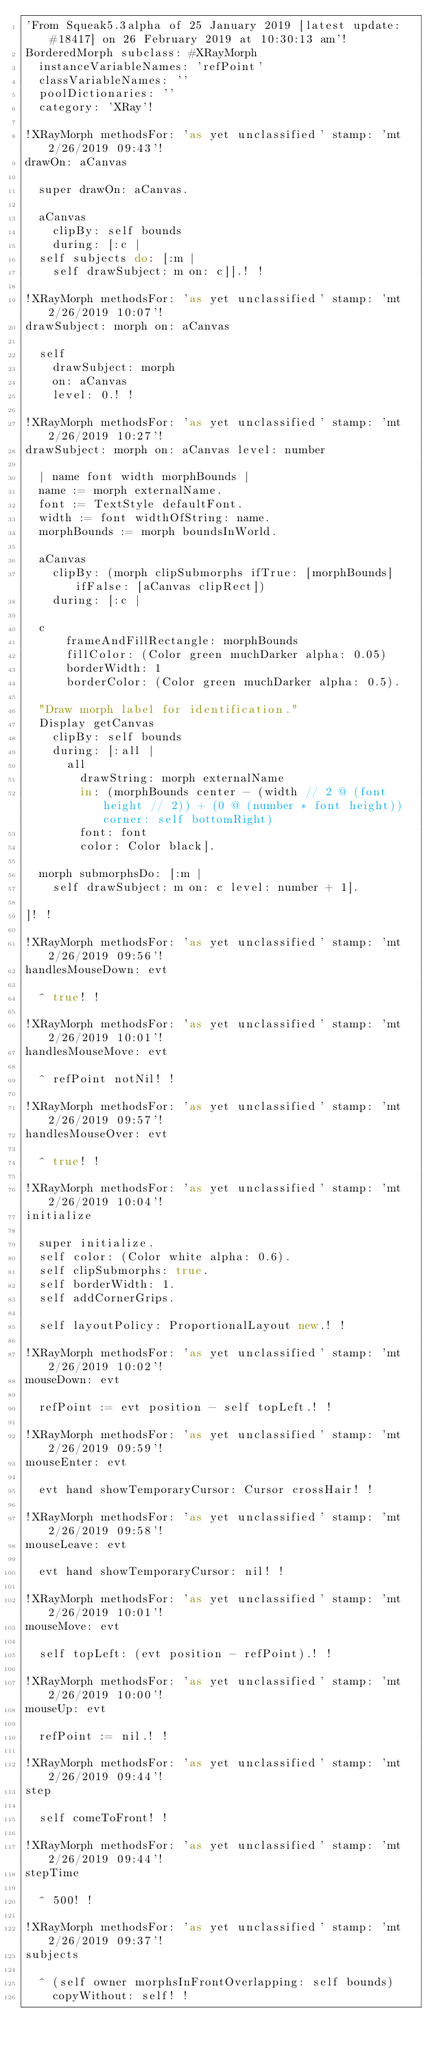<code> <loc_0><loc_0><loc_500><loc_500><_C#_>'From Squeak5.3alpha of 25 January 2019 [latest update: #18417] on 26 February 2019 at 10:30:13 am'!BorderedMorph subclass: #XRayMorph	instanceVariableNames: 'refPoint'	classVariableNames: ''	poolDictionaries: ''	category: 'XRay'!!XRayMorph methodsFor: 'as yet unclassified' stamp: 'mt 2/26/2019 09:43'!drawOn: aCanvas	super drawOn: aCanvas.	aCanvas		clipBy: self bounds		during: [:c |	self subjects do: [:m |		self drawSubject: m on: c]].! !!XRayMorph methodsFor: 'as yet unclassified' stamp: 'mt 2/26/2019 10:07'!drawSubject: morph on: aCanvas	self		drawSubject: morph		on: aCanvas		level: 0.! !!XRayMorph methodsFor: 'as yet unclassified' stamp: 'mt 2/26/2019 10:27'!drawSubject: morph on: aCanvas level: number	| name font width morphBounds |	name := morph externalName.	font := TextStyle defaultFont.	width := font widthOfString: name.	morphBounds := morph boundsInWorld. 	aCanvas		clipBy: (morph clipSubmorphs ifTrue: [morphBounds] ifFalse: [aCanvas clipRect])		during: [:c |	c			frameAndFillRectangle: morphBounds			fillColor: (Color green muchDarker alpha: 0.05)			borderWidth: 1			borderColor: (Color green muchDarker alpha: 0.5).	"Draw morph label for identification."	Display getCanvas		clipBy: self bounds		during: [:all |			all				drawString: morph externalName				in: (morphBounds center - (width // 2 @ (font height // 2)) + (0 @ (number * font height)) corner: self bottomRight)				font: font				color: Color black].	morph submorphsDo: [:m |		self drawSubject: m on: c level: number + 1].	]! !!XRayMorph methodsFor: 'as yet unclassified' stamp: 'mt 2/26/2019 09:56'!handlesMouseDown: evt	^ true! !!XRayMorph methodsFor: 'as yet unclassified' stamp: 'mt 2/26/2019 10:01'!handlesMouseMove: evt	^ refPoint notNil! !!XRayMorph methodsFor: 'as yet unclassified' stamp: 'mt 2/26/2019 09:57'!handlesMouseOver: evt	^ true! !!XRayMorph methodsFor: 'as yet unclassified' stamp: 'mt 2/26/2019 10:04'!initialize	super initialize.	self color: (Color white alpha: 0.6).	self clipSubmorphs: true.	self borderWidth: 1.	self addCornerGrips.		self layoutPolicy: ProportionalLayout new.! !!XRayMorph methodsFor: 'as yet unclassified' stamp: 'mt 2/26/2019 10:02'!mouseDown: evt	refPoint := evt position - self topLeft.! !!XRayMorph methodsFor: 'as yet unclassified' stamp: 'mt 2/26/2019 09:59'!mouseEnter: evt	evt hand showTemporaryCursor: Cursor crossHair! !!XRayMorph methodsFor: 'as yet unclassified' stamp: 'mt 2/26/2019 09:58'!mouseLeave: evt	evt hand showTemporaryCursor: nil! !!XRayMorph methodsFor: 'as yet unclassified' stamp: 'mt 2/26/2019 10:01'!mouseMove: evt	self topLeft: (evt position - refPoint).! !!XRayMorph methodsFor: 'as yet unclassified' stamp: 'mt 2/26/2019 10:00'!mouseUp: evt	refPoint := nil.! !!XRayMorph methodsFor: 'as yet unclassified' stamp: 'mt 2/26/2019 09:44'!step	self comeToFront! !!XRayMorph methodsFor: 'as yet unclassified' stamp: 'mt 2/26/2019 09:44'!stepTime	^ 500! !!XRayMorph methodsFor: 'as yet unclassified' stamp: 'mt 2/26/2019 09:37'!subjects	^ (self owner morphsInFrontOverlapping: self bounds)		copyWithout: self! !</code> 